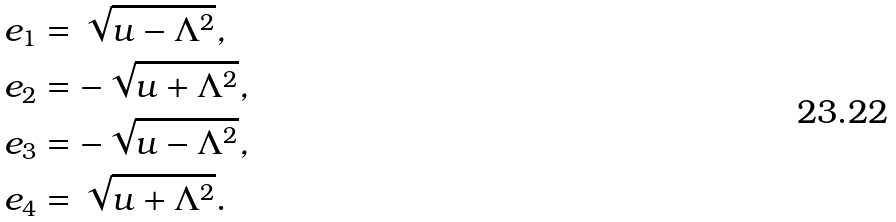<formula> <loc_0><loc_0><loc_500><loc_500>e _ { 1 } & = \sqrt { u - \Lambda ^ { 2 } } , \\ e _ { 2 } & = - \sqrt { u + \Lambda ^ { 2 } } , \\ e _ { 3 } & = - \sqrt { u - \Lambda ^ { 2 } } , \\ e _ { 4 } & = \sqrt { u + \Lambda ^ { 2 } } .</formula> 